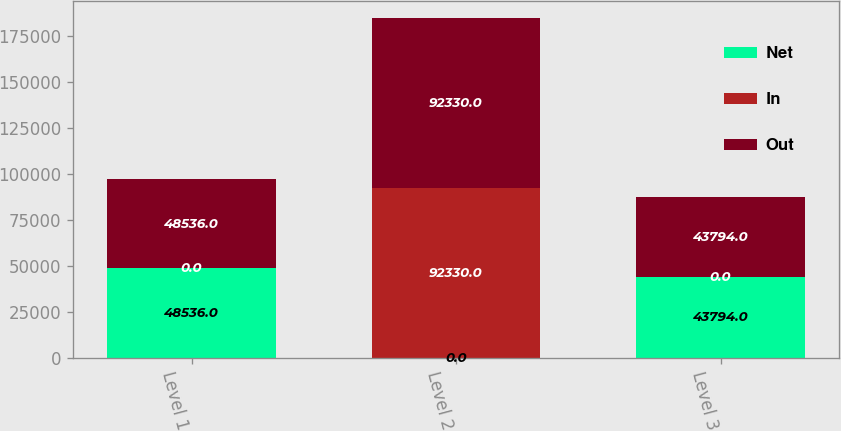Convert chart. <chart><loc_0><loc_0><loc_500><loc_500><stacked_bar_chart><ecel><fcel>Level 1<fcel>Level 2<fcel>Level 3<nl><fcel>Net<fcel>48536<fcel>0<fcel>43794<nl><fcel>In<fcel>0<fcel>92330<fcel>0<nl><fcel>Out<fcel>48536<fcel>92330<fcel>43794<nl></chart> 